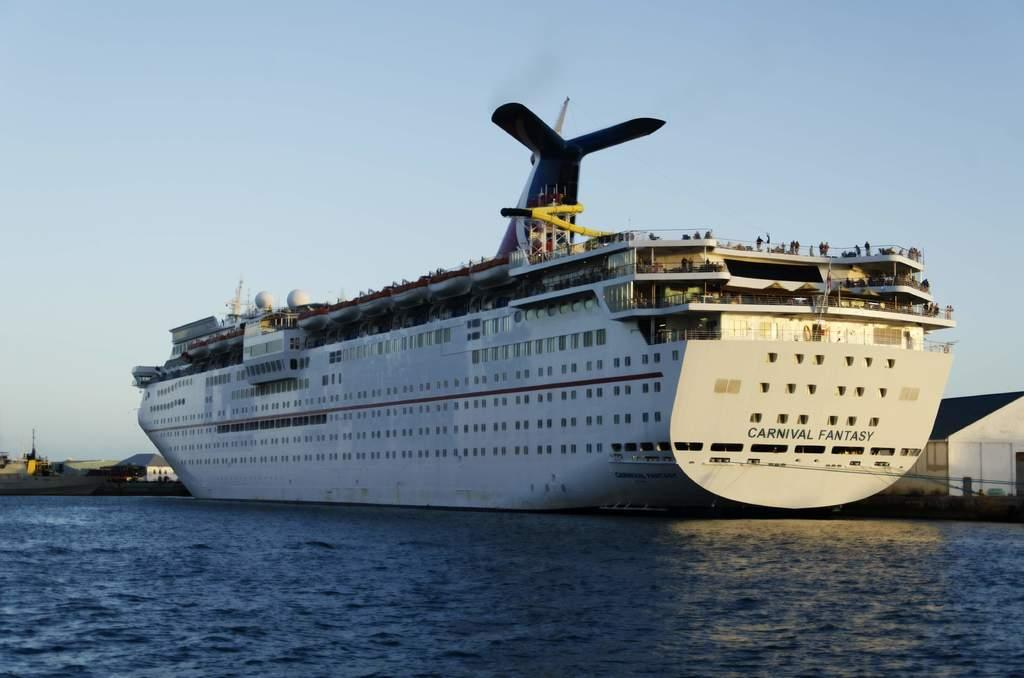What is the main subject of the image? The main subject of the image is a ship. Where is the ship located in the image? The ship is in the water. What can be seen in the background of the image? There are buildings and the sky visible in the background of the image. What type of toys can be seen floating near the ship in the image? There are no toys present in the image; it features a ship in the water with buildings and the sky visible in the background. 